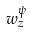Convert formula to latex. <formula><loc_0><loc_0><loc_500><loc_500>w _ { z } ^ { \psi }</formula> 